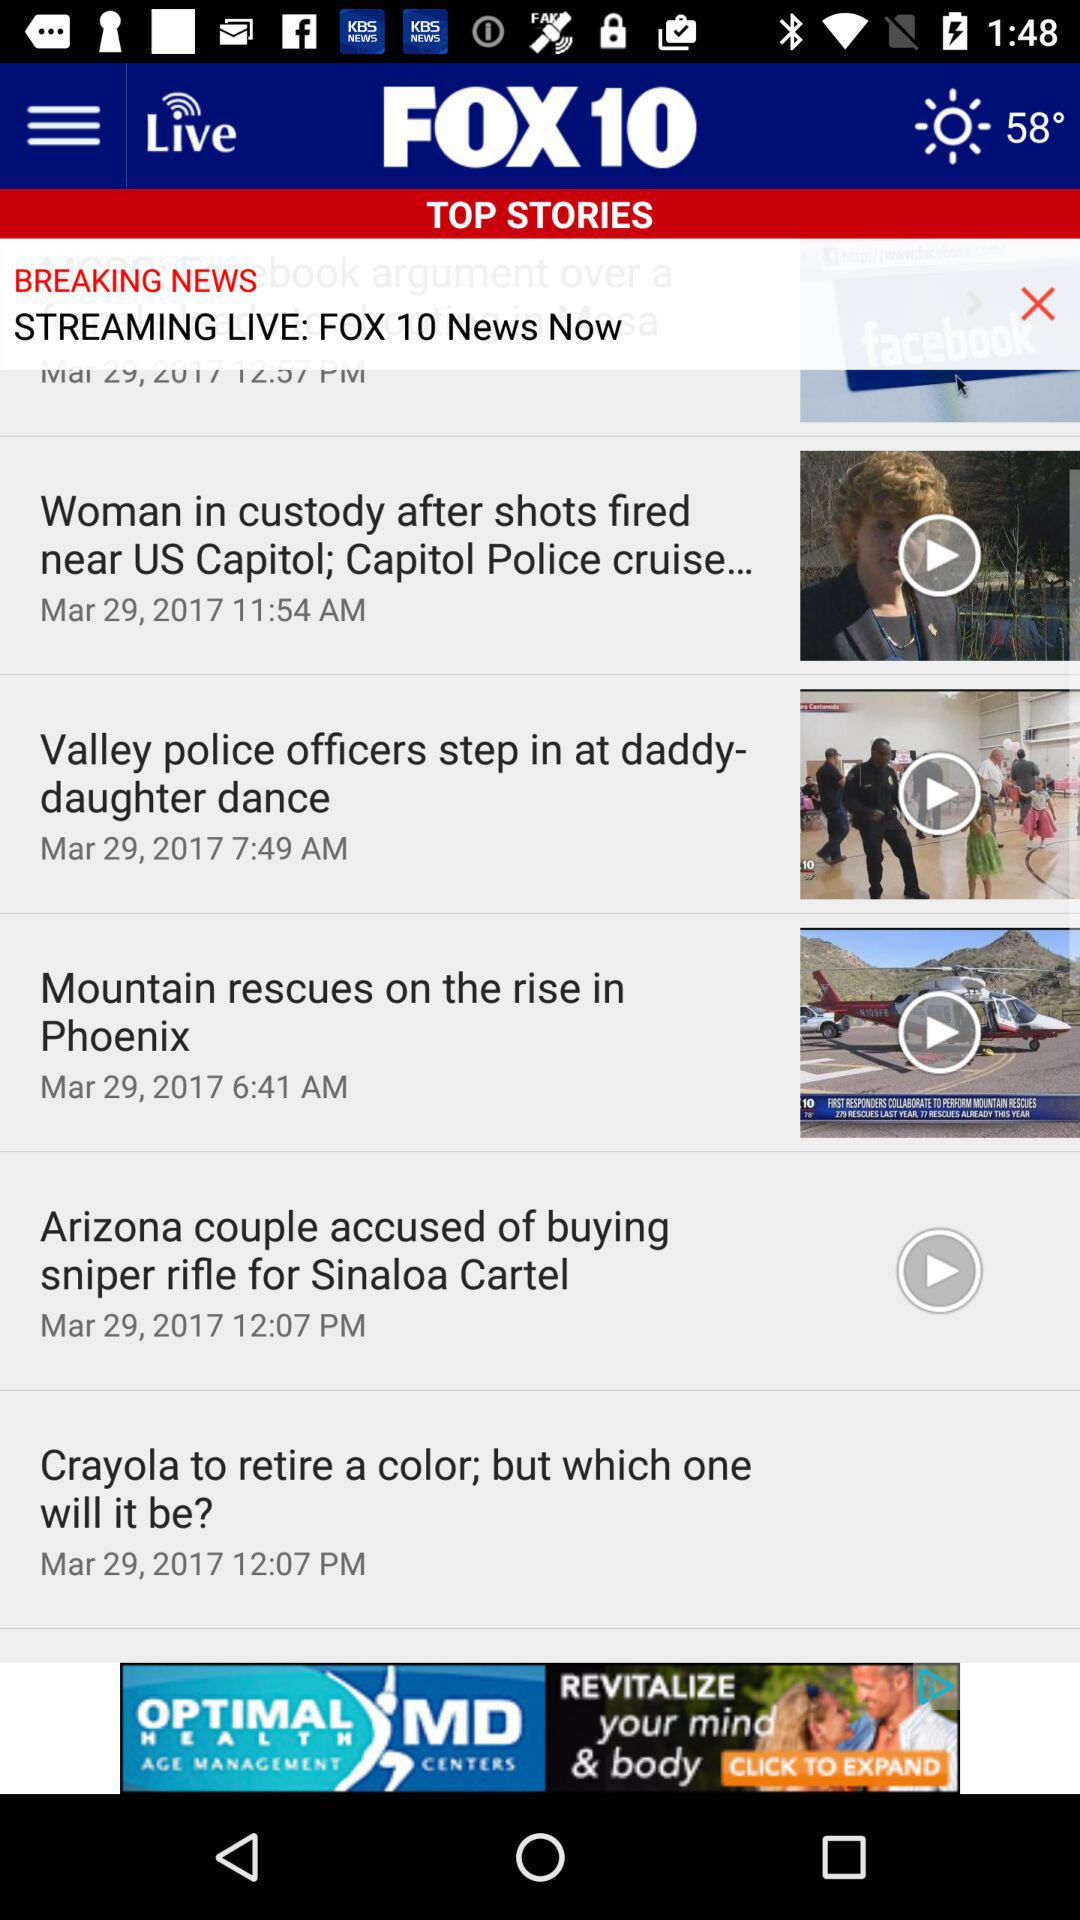What is the date? The date is March 29, 2017. 